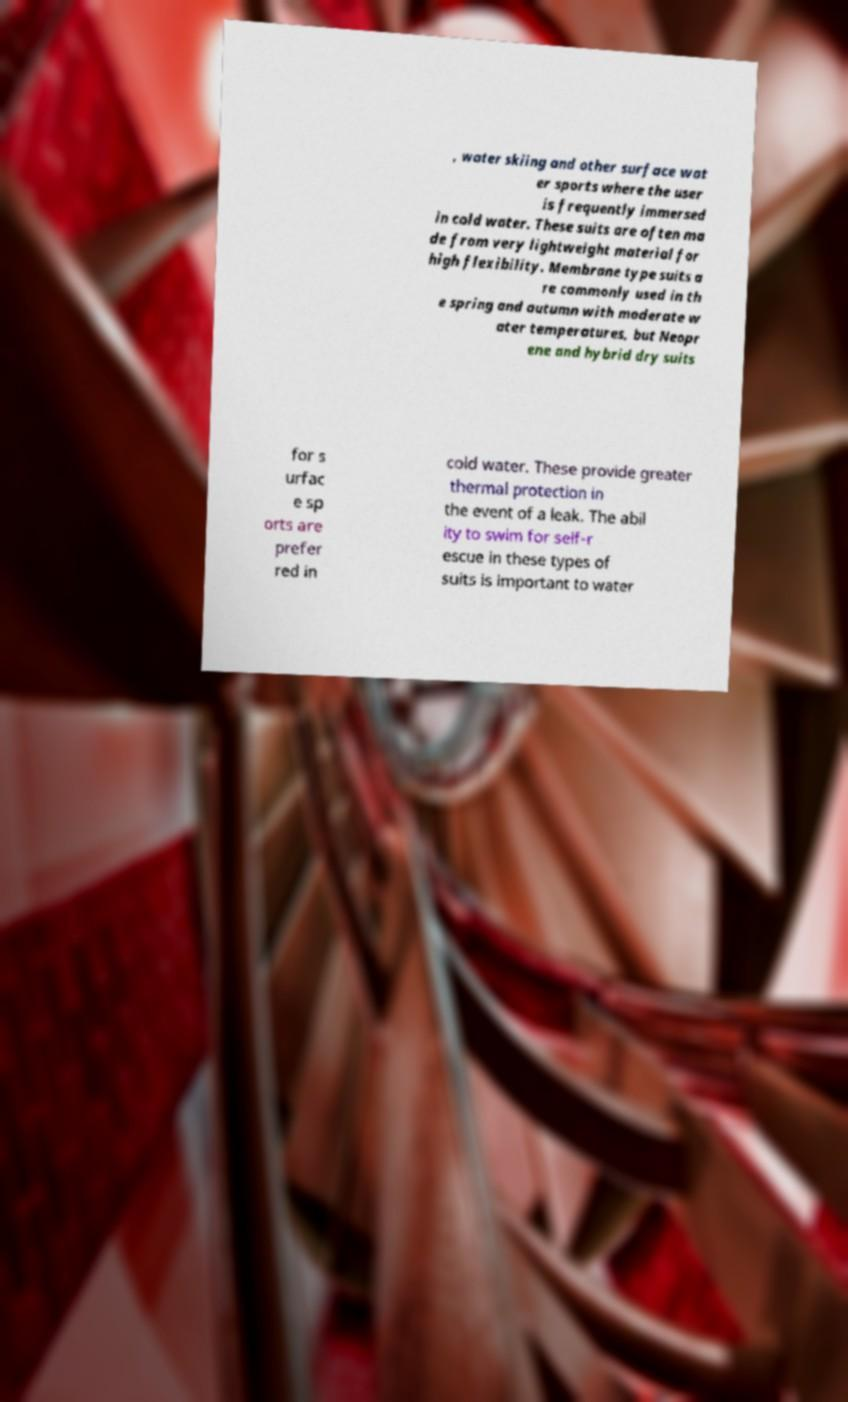Please identify and transcribe the text found in this image. , water skiing and other surface wat er sports where the user is frequently immersed in cold water. These suits are often ma de from very lightweight material for high flexibility. Membrane type suits a re commonly used in th e spring and autumn with moderate w ater temperatures, but Neopr ene and hybrid dry suits for s urfac e sp orts are prefer red in cold water. These provide greater thermal protection in the event of a leak. The abil ity to swim for self-r escue in these types of suits is important to water 